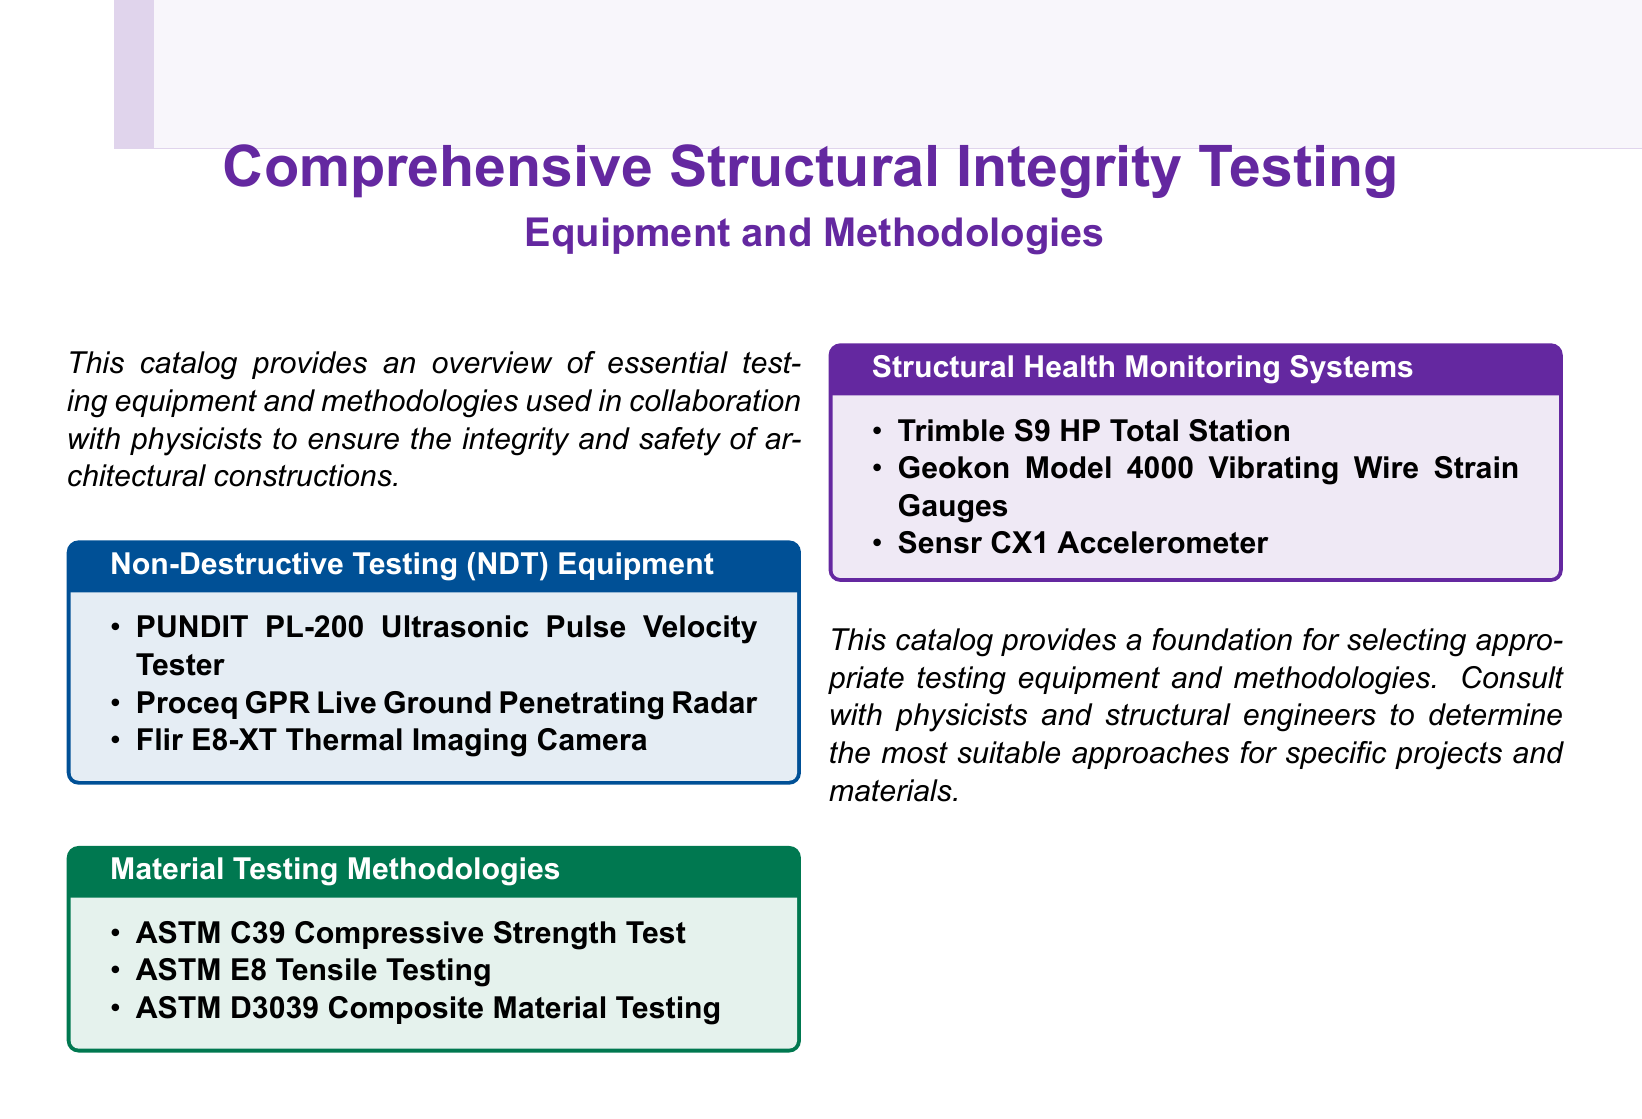What is the main focus of the catalog? The catalog provides an overview of essential testing equipment and methodologies used in collaboration with physicists to ensure the integrity and safety of architectural constructions.
Answer: Structural integrity testing How many types of testing equipment are listed? The document lists a total of three types of non-destructive testing equipment.
Answer: Three What is one of the materials testing methodologies mentioned? The document includes ASTM C39 Compressive Strength Test as one of the methodologies.
Answer: ASTM C39 Compressive Strength Test What color is used for the title background? The color used for the title background is mypurple.
Answer: mypurple Which system is used for structural health monitoring? The Trimble S9 HP Total Station is listed as a system for structural health monitoring.
Answer: Trimble S9 HP Total Station What is the title of the second testing equipment section? The title of the second section in the catalog is "Material Testing Methodologies."
Answer: Material Testing Methodologies How many structural health monitoring systems are described? The document describes three structural health monitoring systems.
Answer: Three What is mentioned as a necessary consultation for project approaches? The document advises consulting with physicists and structural engineers to determine suitable approaches.
Answer: Physicists and structural engineers 